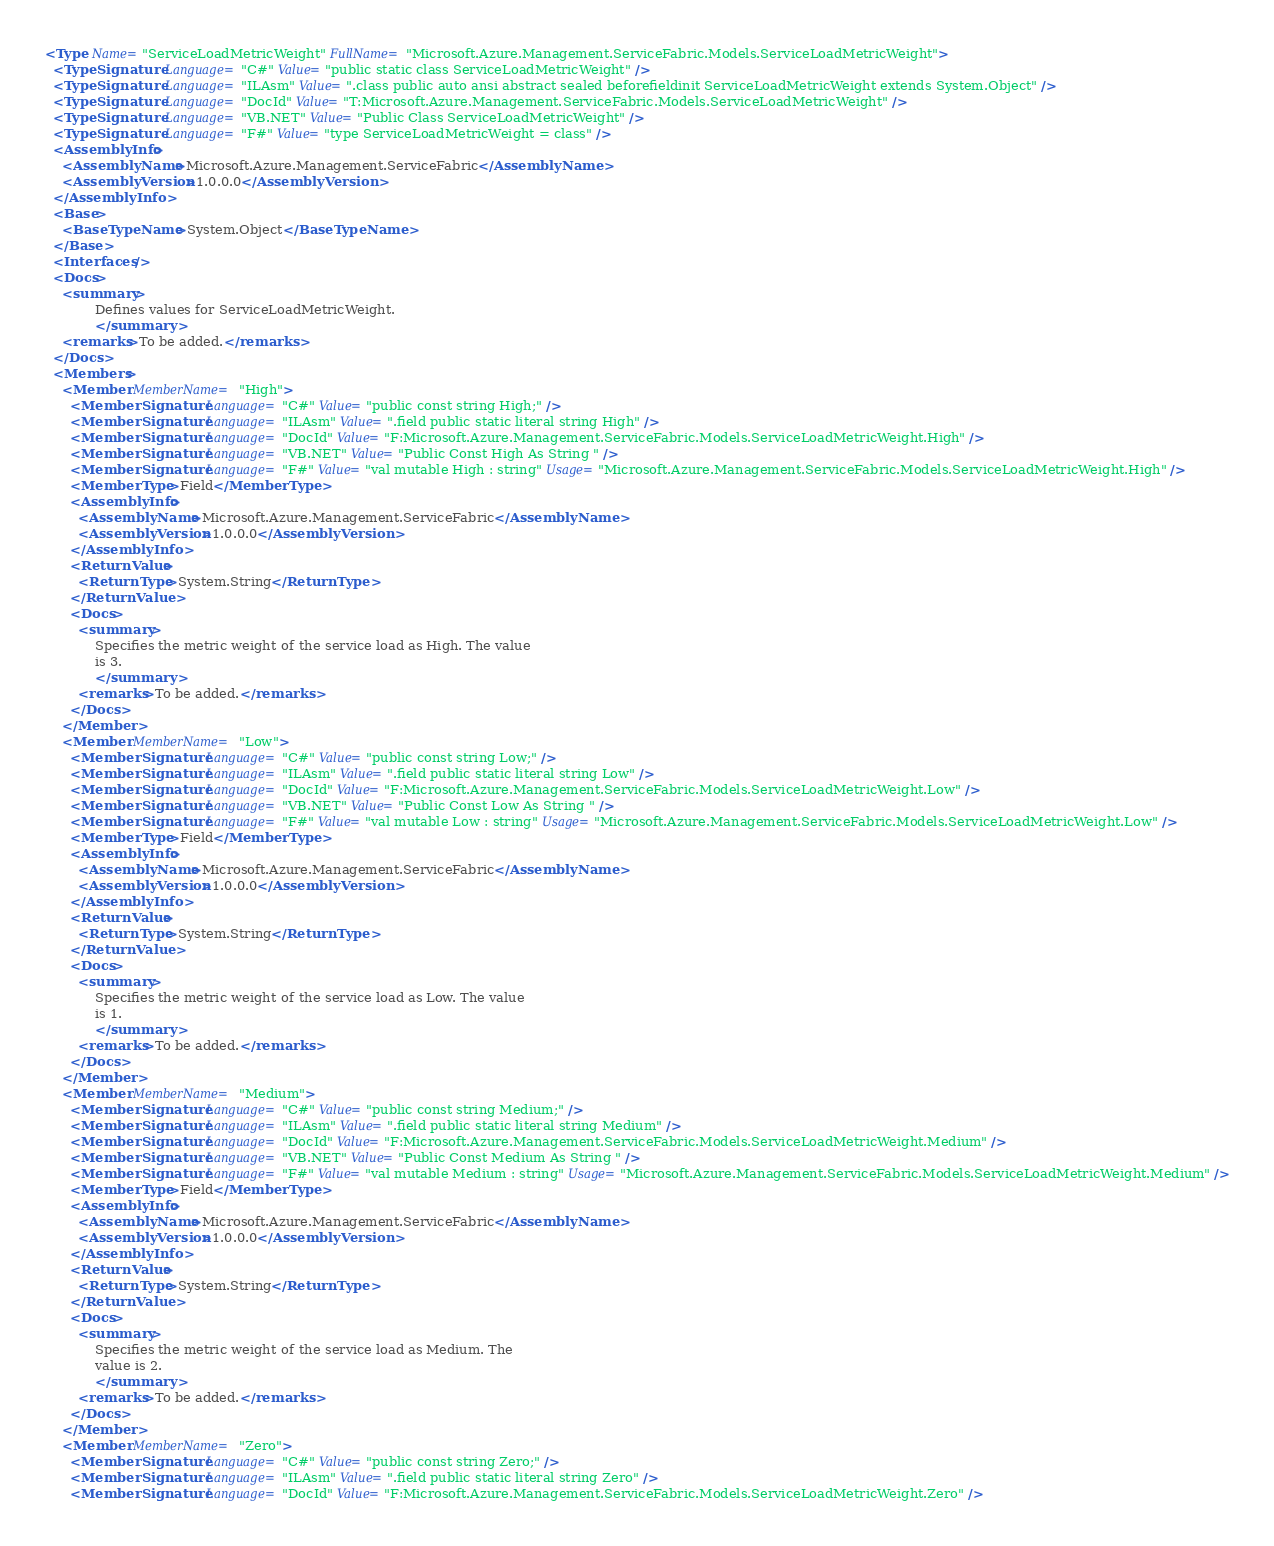Convert code to text. <code><loc_0><loc_0><loc_500><loc_500><_XML_><Type Name="ServiceLoadMetricWeight" FullName="Microsoft.Azure.Management.ServiceFabric.Models.ServiceLoadMetricWeight">
  <TypeSignature Language="C#" Value="public static class ServiceLoadMetricWeight" />
  <TypeSignature Language="ILAsm" Value=".class public auto ansi abstract sealed beforefieldinit ServiceLoadMetricWeight extends System.Object" />
  <TypeSignature Language="DocId" Value="T:Microsoft.Azure.Management.ServiceFabric.Models.ServiceLoadMetricWeight" />
  <TypeSignature Language="VB.NET" Value="Public Class ServiceLoadMetricWeight" />
  <TypeSignature Language="F#" Value="type ServiceLoadMetricWeight = class" />
  <AssemblyInfo>
    <AssemblyName>Microsoft.Azure.Management.ServiceFabric</AssemblyName>
    <AssemblyVersion>1.0.0.0</AssemblyVersion>
  </AssemblyInfo>
  <Base>
    <BaseTypeName>System.Object</BaseTypeName>
  </Base>
  <Interfaces />
  <Docs>
    <summary>
            Defines values for ServiceLoadMetricWeight.
            </summary>
    <remarks>To be added.</remarks>
  </Docs>
  <Members>
    <Member MemberName="High">
      <MemberSignature Language="C#" Value="public const string High;" />
      <MemberSignature Language="ILAsm" Value=".field public static literal string High" />
      <MemberSignature Language="DocId" Value="F:Microsoft.Azure.Management.ServiceFabric.Models.ServiceLoadMetricWeight.High" />
      <MemberSignature Language="VB.NET" Value="Public Const High As String " />
      <MemberSignature Language="F#" Value="val mutable High : string" Usage="Microsoft.Azure.Management.ServiceFabric.Models.ServiceLoadMetricWeight.High" />
      <MemberType>Field</MemberType>
      <AssemblyInfo>
        <AssemblyName>Microsoft.Azure.Management.ServiceFabric</AssemblyName>
        <AssemblyVersion>1.0.0.0</AssemblyVersion>
      </AssemblyInfo>
      <ReturnValue>
        <ReturnType>System.String</ReturnType>
      </ReturnValue>
      <Docs>
        <summary>
            Specifies the metric weight of the service load as High. The value
            is 3.
            </summary>
        <remarks>To be added.</remarks>
      </Docs>
    </Member>
    <Member MemberName="Low">
      <MemberSignature Language="C#" Value="public const string Low;" />
      <MemberSignature Language="ILAsm" Value=".field public static literal string Low" />
      <MemberSignature Language="DocId" Value="F:Microsoft.Azure.Management.ServiceFabric.Models.ServiceLoadMetricWeight.Low" />
      <MemberSignature Language="VB.NET" Value="Public Const Low As String " />
      <MemberSignature Language="F#" Value="val mutable Low : string" Usage="Microsoft.Azure.Management.ServiceFabric.Models.ServiceLoadMetricWeight.Low" />
      <MemberType>Field</MemberType>
      <AssemblyInfo>
        <AssemblyName>Microsoft.Azure.Management.ServiceFabric</AssemblyName>
        <AssemblyVersion>1.0.0.0</AssemblyVersion>
      </AssemblyInfo>
      <ReturnValue>
        <ReturnType>System.String</ReturnType>
      </ReturnValue>
      <Docs>
        <summary>
            Specifies the metric weight of the service load as Low. The value
            is 1.
            </summary>
        <remarks>To be added.</remarks>
      </Docs>
    </Member>
    <Member MemberName="Medium">
      <MemberSignature Language="C#" Value="public const string Medium;" />
      <MemberSignature Language="ILAsm" Value=".field public static literal string Medium" />
      <MemberSignature Language="DocId" Value="F:Microsoft.Azure.Management.ServiceFabric.Models.ServiceLoadMetricWeight.Medium" />
      <MemberSignature Language="VB.NET" Value="Public Const Medium As String " />
      <MemberSignature Language="F#" Value="val mutable Medium : string" Usage="Microsoft.Azure.Management.ServiceFabric.Models.ServiceLoadMetricWeight.Medium" />
      <MemberType>Field</MemberType>
      <AssemblyInfo>
        <AssemblyName>Microsoft.Azure.Management.ServiceFabric</AssemblyName>
        <AssemblyVersion>1.0.0.0</AssemblyVersion>
      </AssemblyInfo>
      <ReturnValue>
        <ReturnType>System.String</ReturnType>
      </ReturnValue>
      <Docs>
        <summary>
            Specifies the metric weight of the service load as Medium. The
            value is 2.
            </summary>
        <remarks>To be added.</remarks>
      </Docs>
    </Member>
    <Member MemberName="Zero">
      <MemberSignature Language="C#" Value="public const string Zero;" />
      <MemberSignature Language="ILAsm" Value=".field public static literal string Zero" />
      <MemberSignature Language="DocId" Value="F:Microsoft.Azure.Management.ServiceFabric.Models.ServiceLoadMetricWeight.Zero" /></code> 